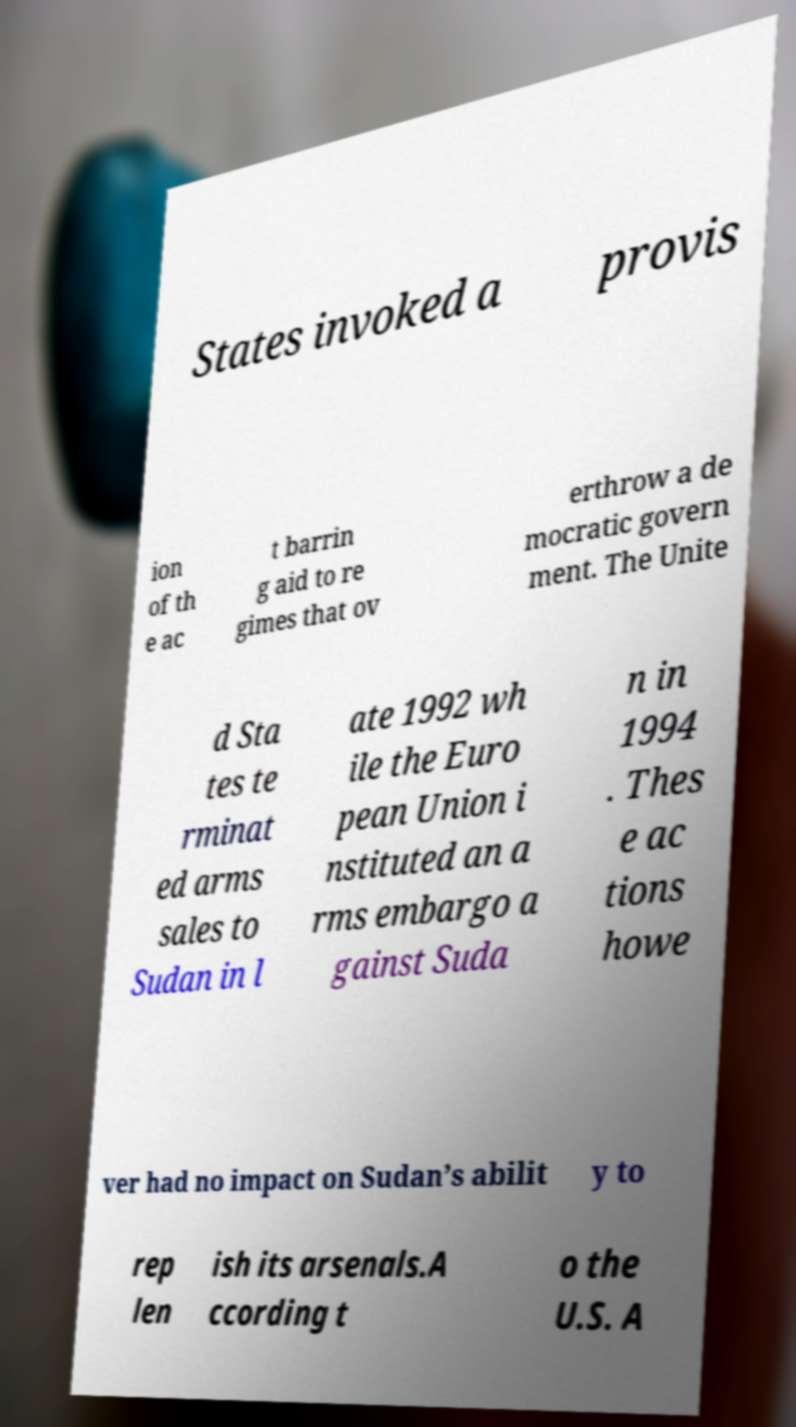Could you extract and type out the text from this image? States invoked a provis ion of th e ac t barrin g aid to re gimes that ov erthrow a de mocratic govern ment. The Unite d Sta tes te rminat ed arms sales to Sudan in l ate 1992 wh ile the Euro pean Union i nstituted an a rms embargo a gainst Suda n in 1994 . Thes e ac tions howe ver had no impact on Sudan’s abilit y to rep len ish its arsenals.A ccording t o the U.S. A 